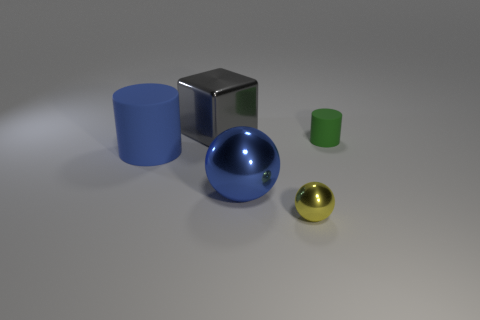Add 1 metallic objects. How many objects exist? 6 Subtract all green cylinders. How many cylinders are left? 1 Subtract all cubes. How many objects are left? 4 Subtract 1 cylinders. How many cylinders are left? 1 Subtract all gray cylinders. Subtract all cyan spheres. How many cylinders are left? 2 Subtract all yellow cylinders. How many yellow balls are left? 1 Subtract all tiny cylinders. Subtract all small metal objects. How many objects are left? 3 Add 3 large blue cylinders. How many large blue cylinders are left? 4 Add 1 matte objects. How many matte objects exist? 3 Subtract 0 cyan blocks. How many objects are left? 5 